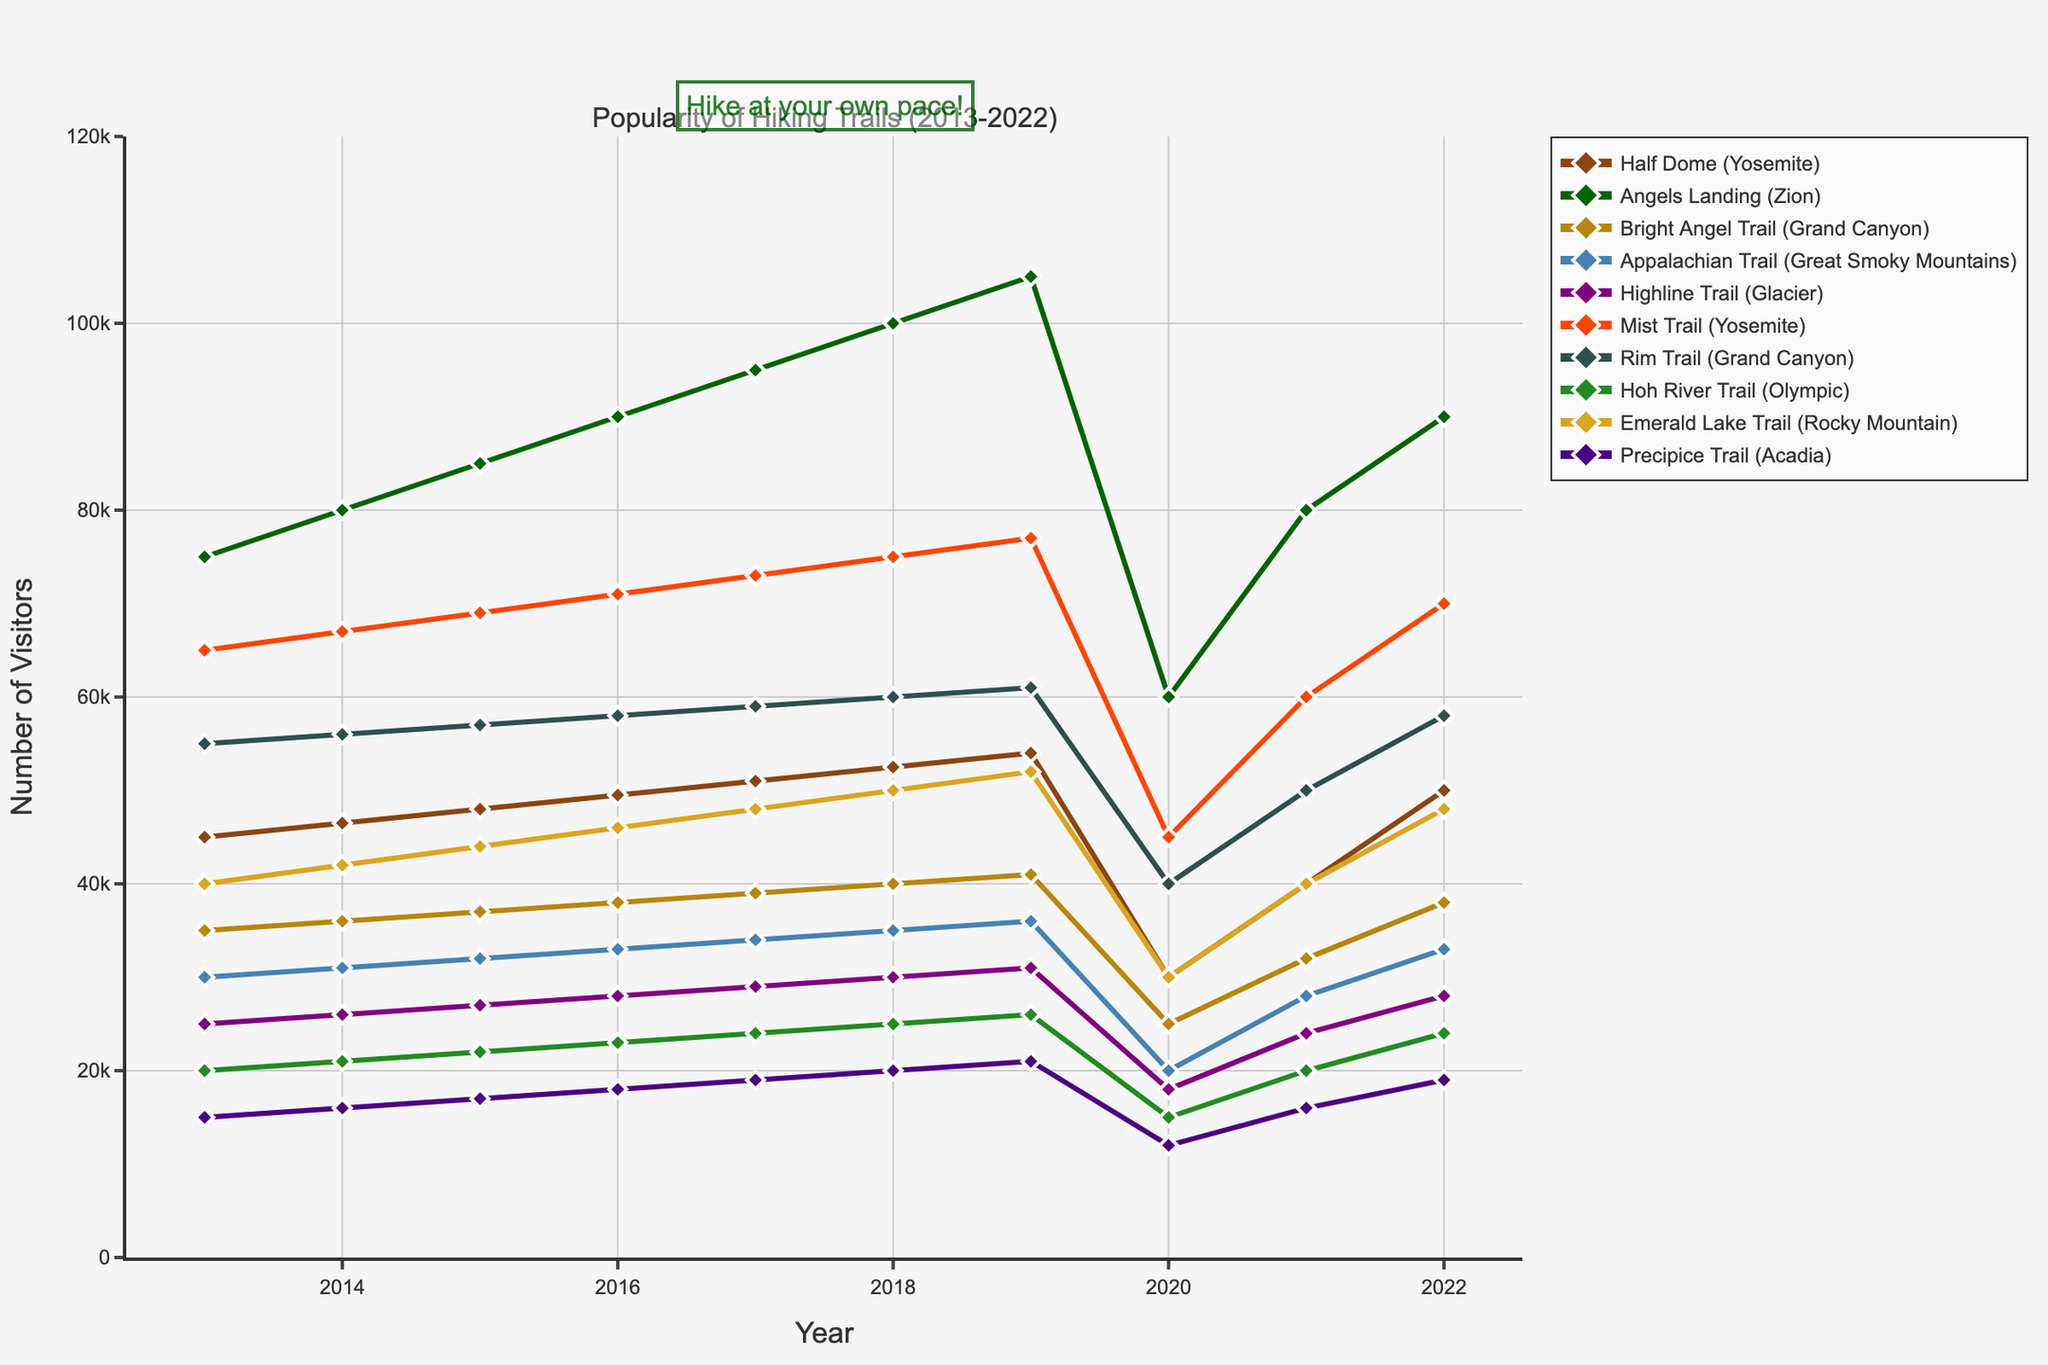Which trail had the highest number of visitors in 2019? Look for the trail with the highest value on the y-axis label in the year 2019. The trail that stands out with the highest peak in 2019 is Angels Landing (Zion).
Answer: Angels Landing (Zion) Among Half Dome (Yosemite) and Bright Angel Trail (Grand Canyon), which trail had more visitors in 2018? Compare the values of both trails in 2018 by checking their respective points on the line chart. Half Dome (Yosemite) has a higher value compared to Bright Angel Trail (Grand Canyon) in 2018.
Answer: Half Dome (Yosemite) What was the average number of visitors for the Rim Trail (Grand Canyon) from 2013 to 2022? Sum the annual visitor numbers of the Rim Trail for the years 2013 to 2022 and divide by the number of years (10). Sum = 55,000 + 56,000 + 57,000 + 58,000 + 59,000 + 60,000 + 61,000 + 40,000 + 50,000 + 58,000 = 554,000, then divide by 10.
Answer: 55,400 Which trail experienced the largest drop in visitors between 2019 and 2020? Calculate the difference in visitor numbers for each trail between 2019 and 2020. The trail with the maximum difference is Angels Landing (Zion), dropping from 105,000 to 60,000.
Answer: Angels Landing (Zion) On which trail did visitor numbers increase steadily every year from 2013 to 2019? Look for a trail where the visitor numbers show a consistent upward trend with no drops between 2013 and 2019. Mist Trail (Yosemite) shows a steady increase every year from 2013 to 2019.
Answer: Mist Trail (Yosemite) Compare the number of visitors at Appalachian Trail (Great Smoky Mountains) in 2014 with that in 2021. Which year had more visitors and what's the difference? Look at the values for the Appalachian Trail for the years 2014 and 2021. 2014 had 31,000 visitors while 2021 had 28,000 visitors, hence 2014 had more visitors. The difference is 31,000 - 28,000 = 3,000.
Answer: 2014, 3,000 Did any trail surpass 100,000 visitors? If yes, which one(s) and in which year(s)? Identify any peaks above 100,000 on the y-axis of the chart. Angels Landing (Zion) surpassed 100,000 visitors in 2018 and 2019.
Answer: Angels Landing (Zion) in 2018 and 2019 What's the median number of visitors for the Emerald Lake Trail (Rocky Mountain) over the decade? Arrange the annual visitor numbers for Emerald Lake Trail from 2013 to 2022 in ascending order and find the median. Values: 30,000, 40,000, 42,000, 44,000, 46,000, 48,000, 48,000, 50,000, 52,000, and 60,000. Median is the average of 5th and 6th values, (48,000 + 48,000)/2.
Answer: 48,000 Which trail had the fewest visitors in 2017? Identify the trail with the lowest value on the y-axis for the year 2017. The Precipice Trail (Acadia) had the fewest visitors in 2017.
Answer: Precipice Trail (Acadia) Has the Half Dome (Yosemite) always had more visitors than the Hoh River Trail (Olympic) every year? Compare the yearly visitor counts of Half Dome with Hoh River Trail across all years. Half Dome consistently had more visitors each year.
Answer: Yes 